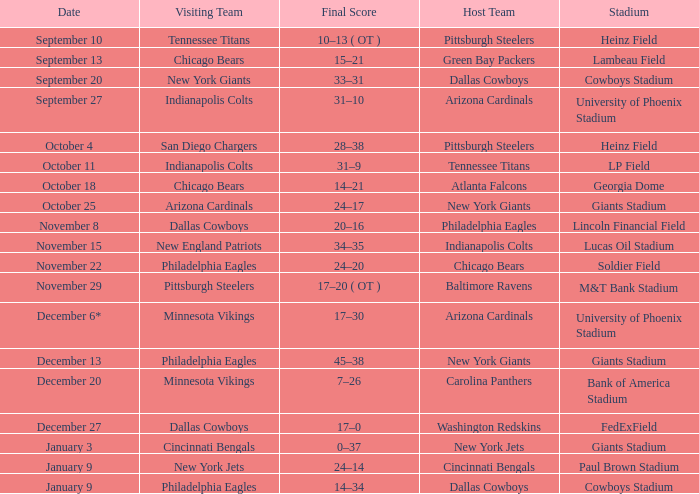Tell me the visiting team for october 4 San Diego Chargers. 